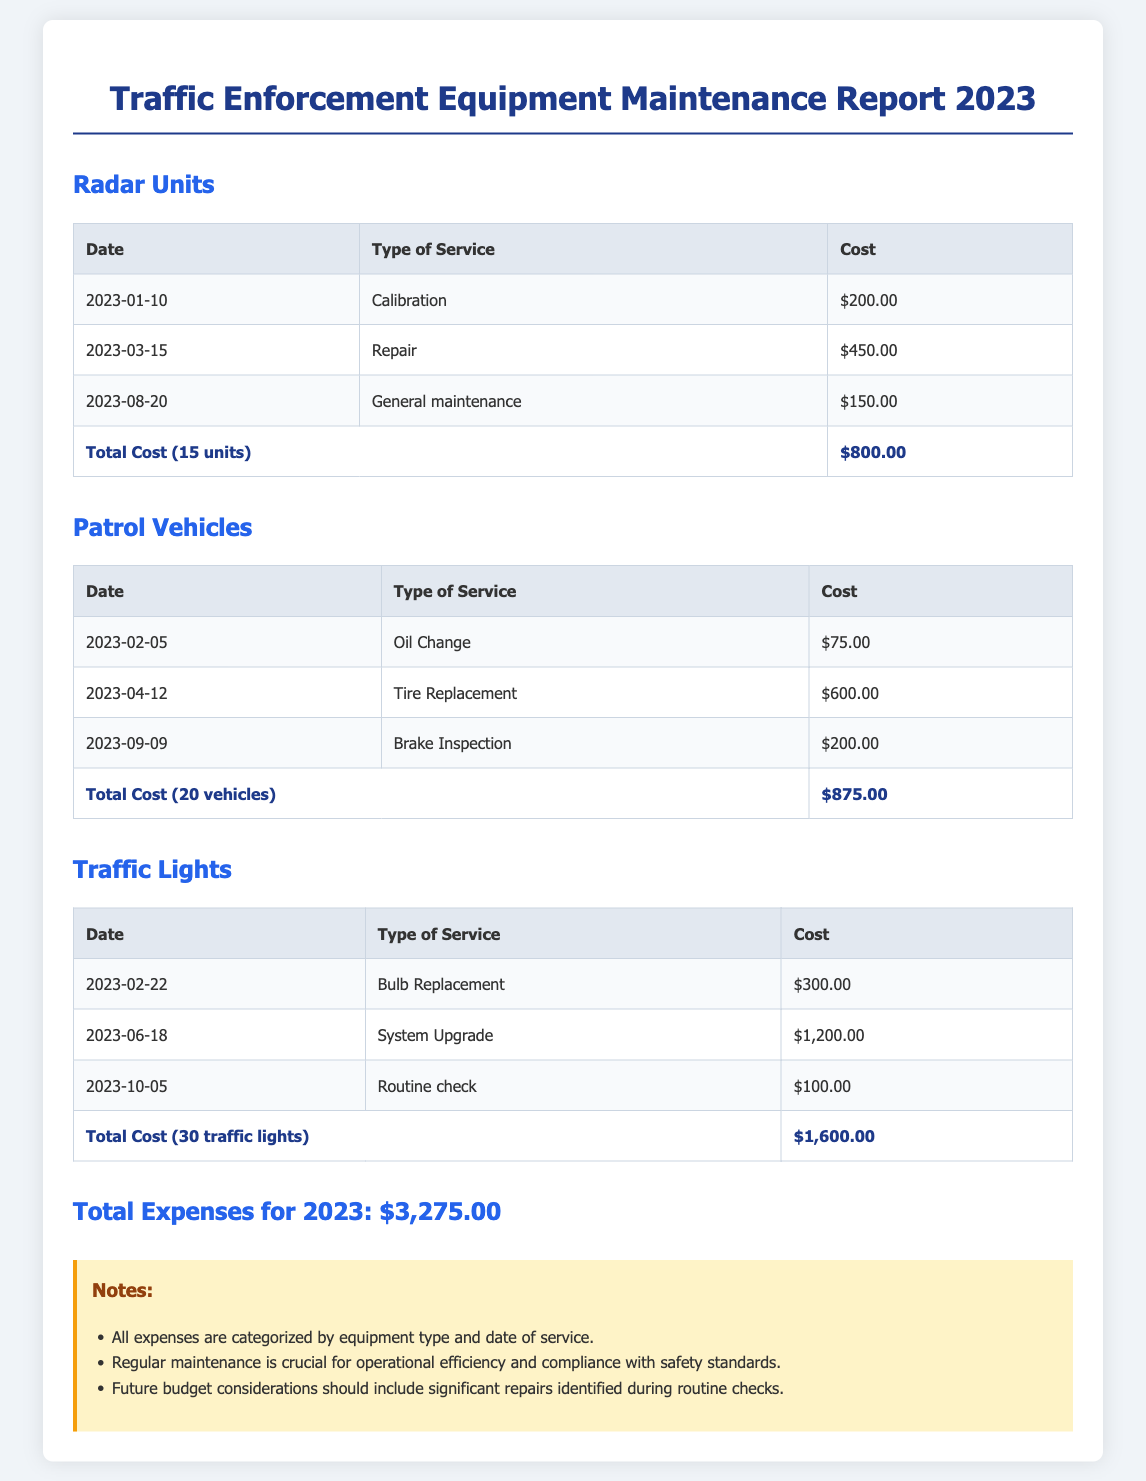What is the date of the calibration service for Radar Units? The date listed for the calibration service is specifically mentioned in the Radar Units section of the document.
Answer: 2023-01-10 What was the total cost for maintaining the Traffic Lights? The total cost is summarized at the end of the Traffic Lights section after accounting for all listed services and their costs.
Answer: $1,600.00 How many Patrol Vehicles were serviced? The total number of vehicles serviced is noted in the total cost row for Patrol Vehicles.
Answer: 20 vehicles What type of service was performed on March 15, 2023? The type of service performed on this date is explicitly documented under the Radar Units section.
Answer: Repair What is the total expense for 2023? The overall total expense for the year is clearly stated at the end of the report and summarizes all equipment costs.
Answer: $3,275.00 How much did the tire replacement for Patrol Vehicles cost? The specific cost for the tire replacement is listed in the Patrol Vehicles section of the document.
Answer: $600.00 What service was done on February 22, 2023, for Traffic Lights? The type of service on this date is categorized in the Traffic Lights section of the report.
Answer: Bulb Replacement How many units of Radar were maintained? The total number of Radar units serviced is indicated in the total cost section for Radar Units.
Answer: 15 units What is the main note about regular maintenance? One of the critical notes regarding maintenance is presented at the bottom of the document.
Answer: Operational efficiency and compliance with safety standards 